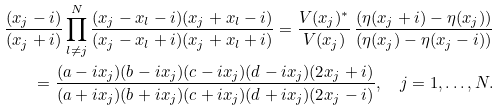Convert formula to latex. <formula><loc_0><loc_0><loc_500><loc_500>\frac { ( x _ { j } - i ) } { ( x _ { j } + i ) } \prod _ { l \neq j } ^ { N } \frac { ( x _ { j } - x _ { l } - i ) ( x _ { j } + x _ { l } - i ) } { ( x _ { j } - x _ { l } + i ) ( x _ { j } + x _ { l } + i ) } = \frac { V ( x _ { j } ) ^ { * } } { V ( x _ { j } ) } \, \frac { ( \eta ( x _ { j } + i ) - \eta ( x _ { j } ) ) } { ( \eta ( x _ { j } ) - \eta ( x _ { j } - i ) ) } \\ = \frac { ( a - i x _ { j } ) ( b - i x _ { j } ) ( c - i x _ { j } ) ( d - i x _ { j } ) ( 2 x _ { j } + i ) } { ( a + i x _ { j } ) ( b + i x _ { j } ) ( c + i x _ { j } ) ( d + i x _ { j } ) ( 2 x _ { j } - i ) } , \quad j = 1 , \dots , N .</formula> 